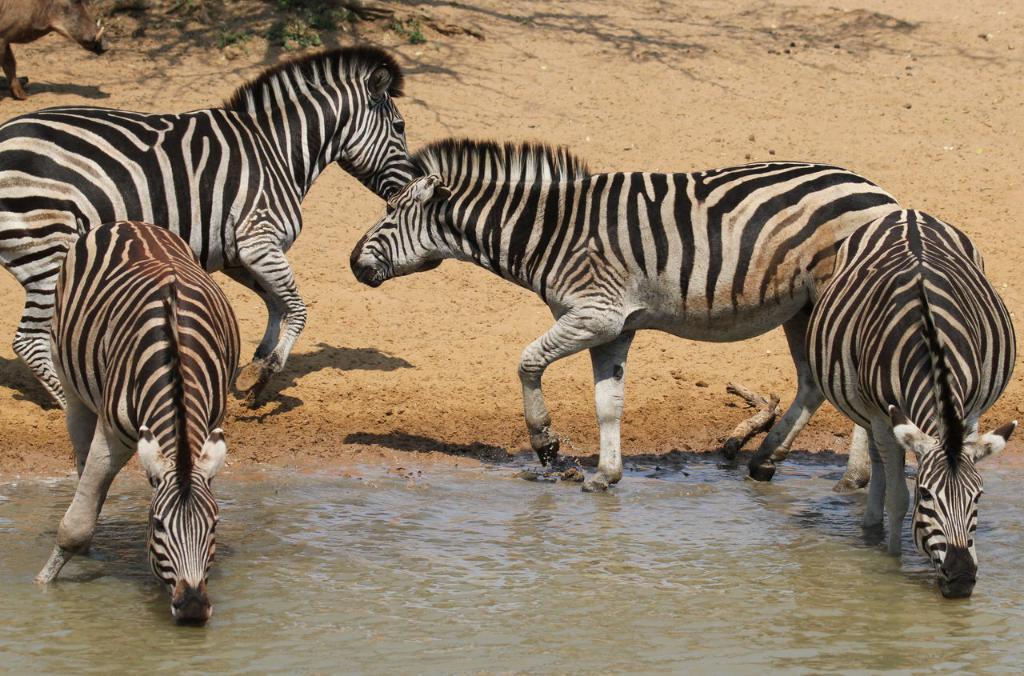Could you give a brief overview of what you see in this image? In this image we can see there are few animals and there are two giraffes placing their mounts in the water. In the background, we can see the shadow of a tree on the surface of the sand. 